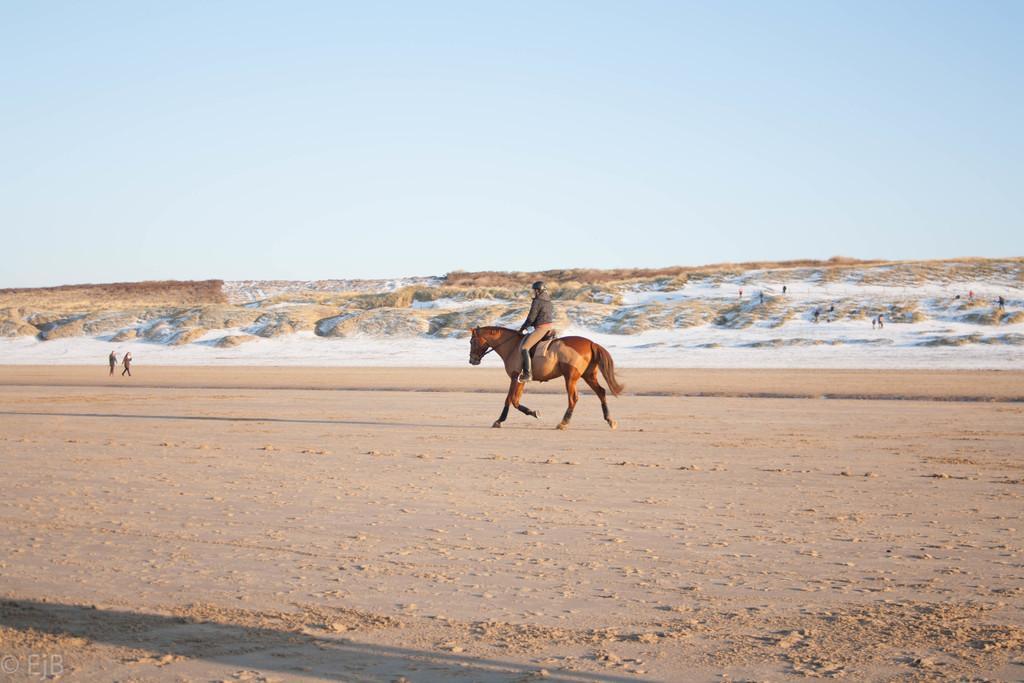Can you describe this image briefly? A person is riding the horse, this horse is in brown color. At the top it's a sky. 